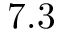Convert formula to latex. <formula><loc_0><loc_0><loc_500><loc_500>7 . 3</formula> 